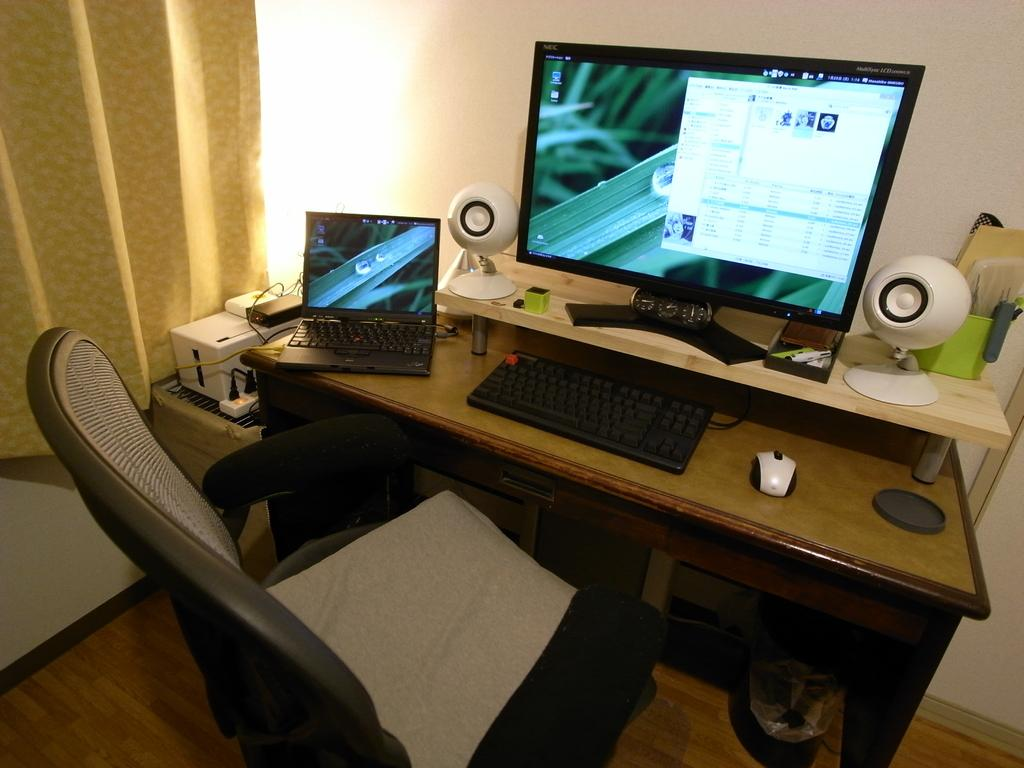What type of electronic devices are present in the image? There is a computer and a laptop in the image. What is the purpose of the chair in the image? The chair is likely for someone to sit on while using the computer or laptop. What can be seen on the table in the image? There are two speakers on the table in the image. Where is the cactus located in the image? There is no cactus present in the image. What type of pain is being experienced by the person in the image? There is no person present in the image, so it is impossible to determine if they are experiencing any pain. 